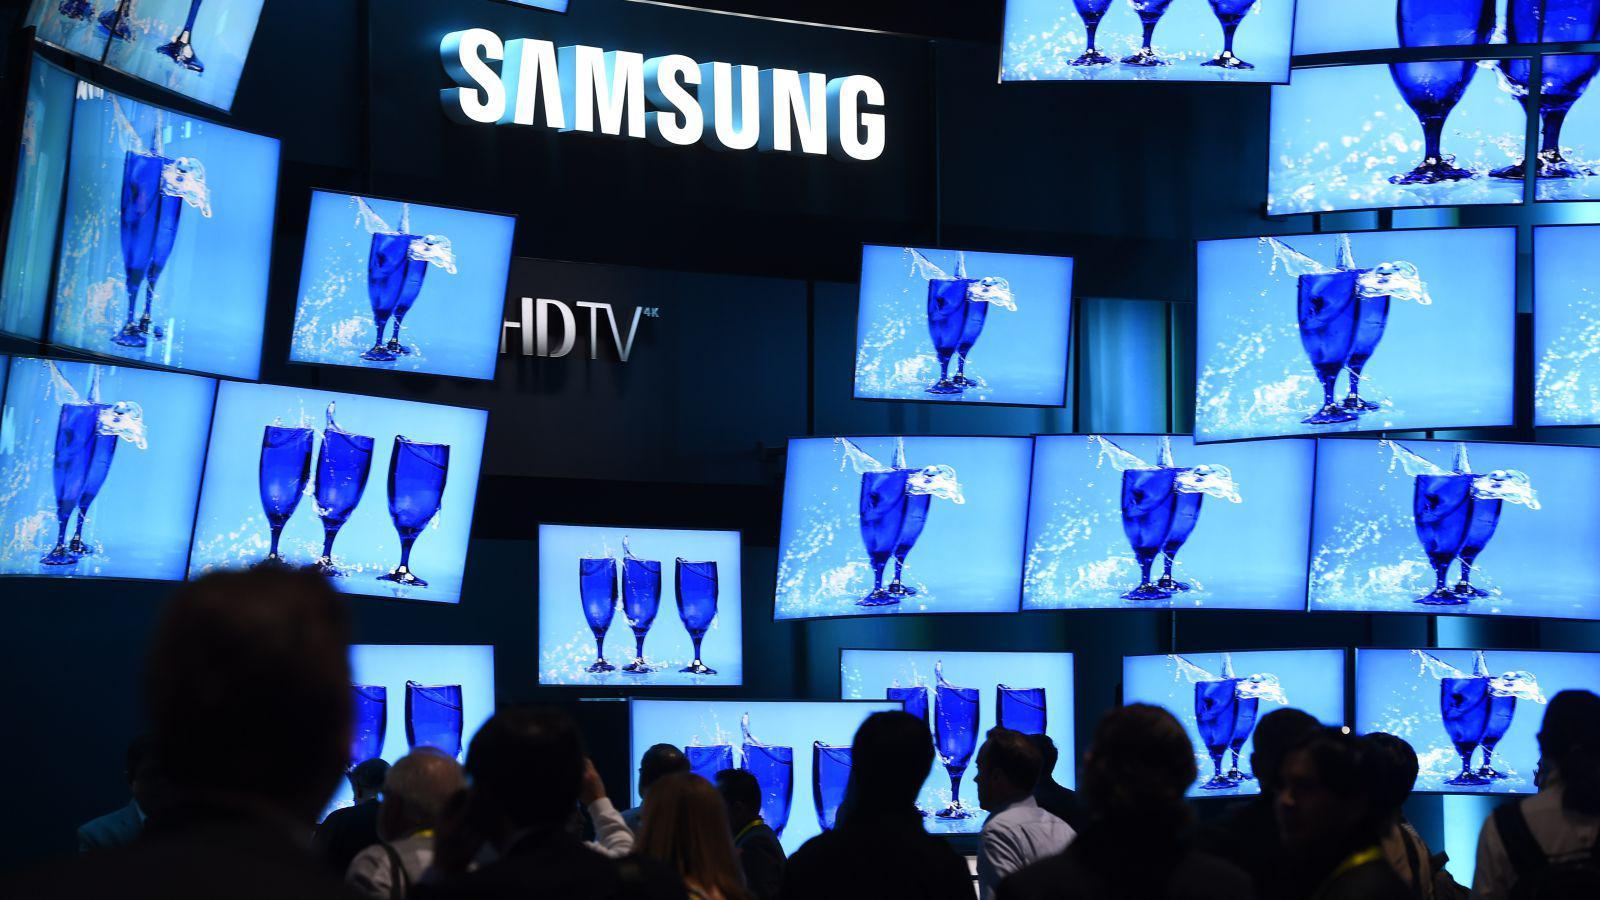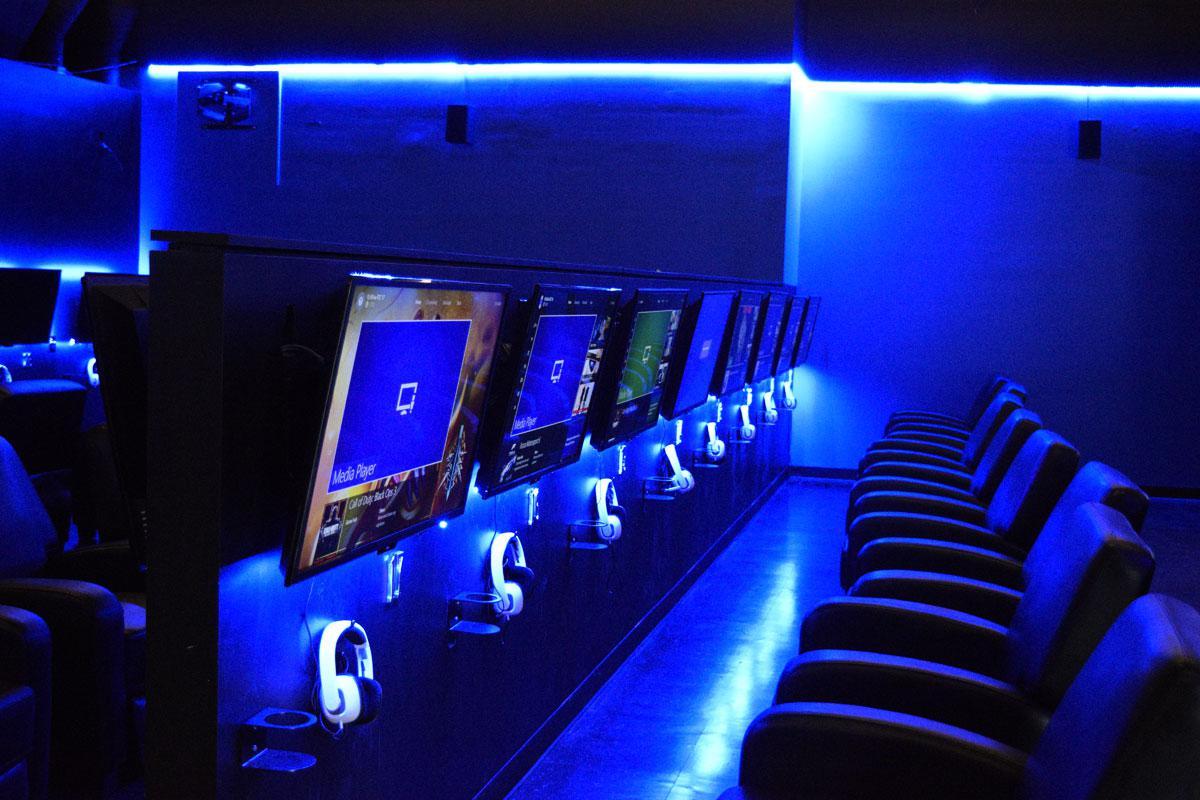The first image is the image on the left, the second image is the image on the right. Examine the images to the left and right. Is the description "Chairs are available for people to view the screens in at least one of the images." accurate? Answer yes or no. Yes. 